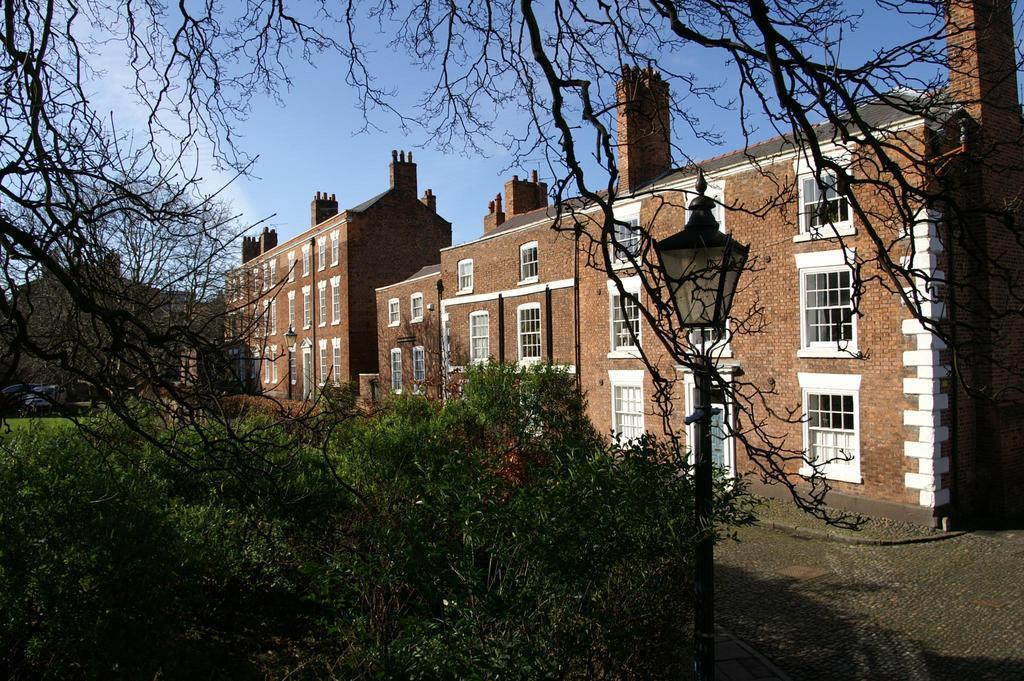What type of structures can be seen in the image? There are buildings in the image. What natural elements are present in the image? There are trees in the image. What are the light sources in the image? There are light poles in the image. What is visible in the background of the image? The sky is visible in the image. What can be used for walking or traveling in the image? There is a path in the image. What type of competition is taking place in the image? There is no competition present in the image. How does the image provide support for the trees? The image does not provide support for the trees; it is a static representation of the scene. 